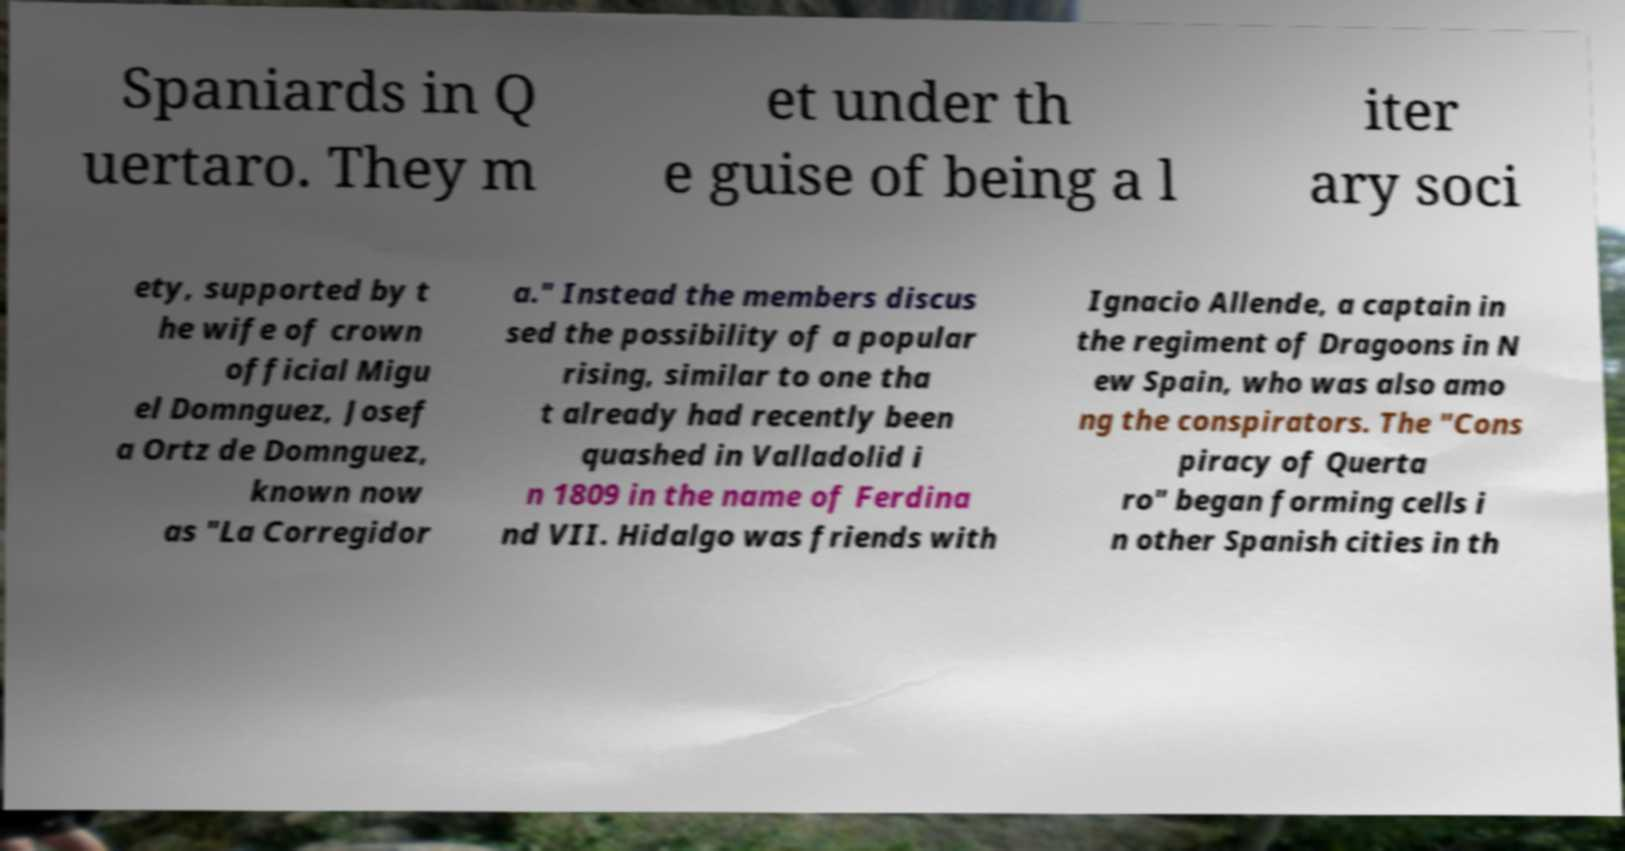Please identify and transcribe the text found in this image. Spaniards in Q uertaro. They m et under th e guise of being a l iter ary soci ety, supported by t he wife of crown official Migu el Domnguez, Josef a Ortz de Domnguez, known now as "La Corregidor a." Instead the members discus sed the possibility of a popular rising, similar to one tha t already had recently been quashed in Valladolid i n 1809 in the name of Ferdina nd VII. Hidalgo was friends with Ignacio Allende, a captain in the regiment of Dragoons in N ew Spain, who was also amo ng the conspirators. The "Cons piracy of Querta ro" began forming cells i n other Spanish cities in th 